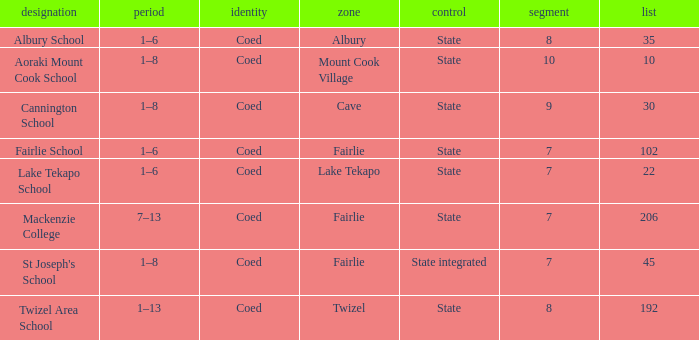What is the total Decile that has a state authority, fairlie area and roll smarter than 206? 1.0. 